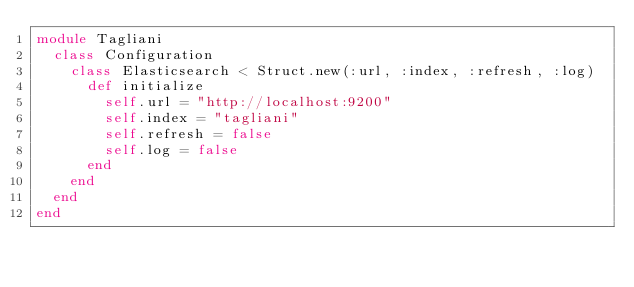<code> <loc_0><loc_0><loc_500><loc_500><_Ruby_>module Tagliani
  class Configuration
    class Elasticsearch < Struct.new(:url, :index, :refresh, :log)
      def initialize
        self.url = "http://localhost:9200"
        self.index = "tagliani"
        self.refresh = false
        self.log = false
      end
    end
  end
end</code> 